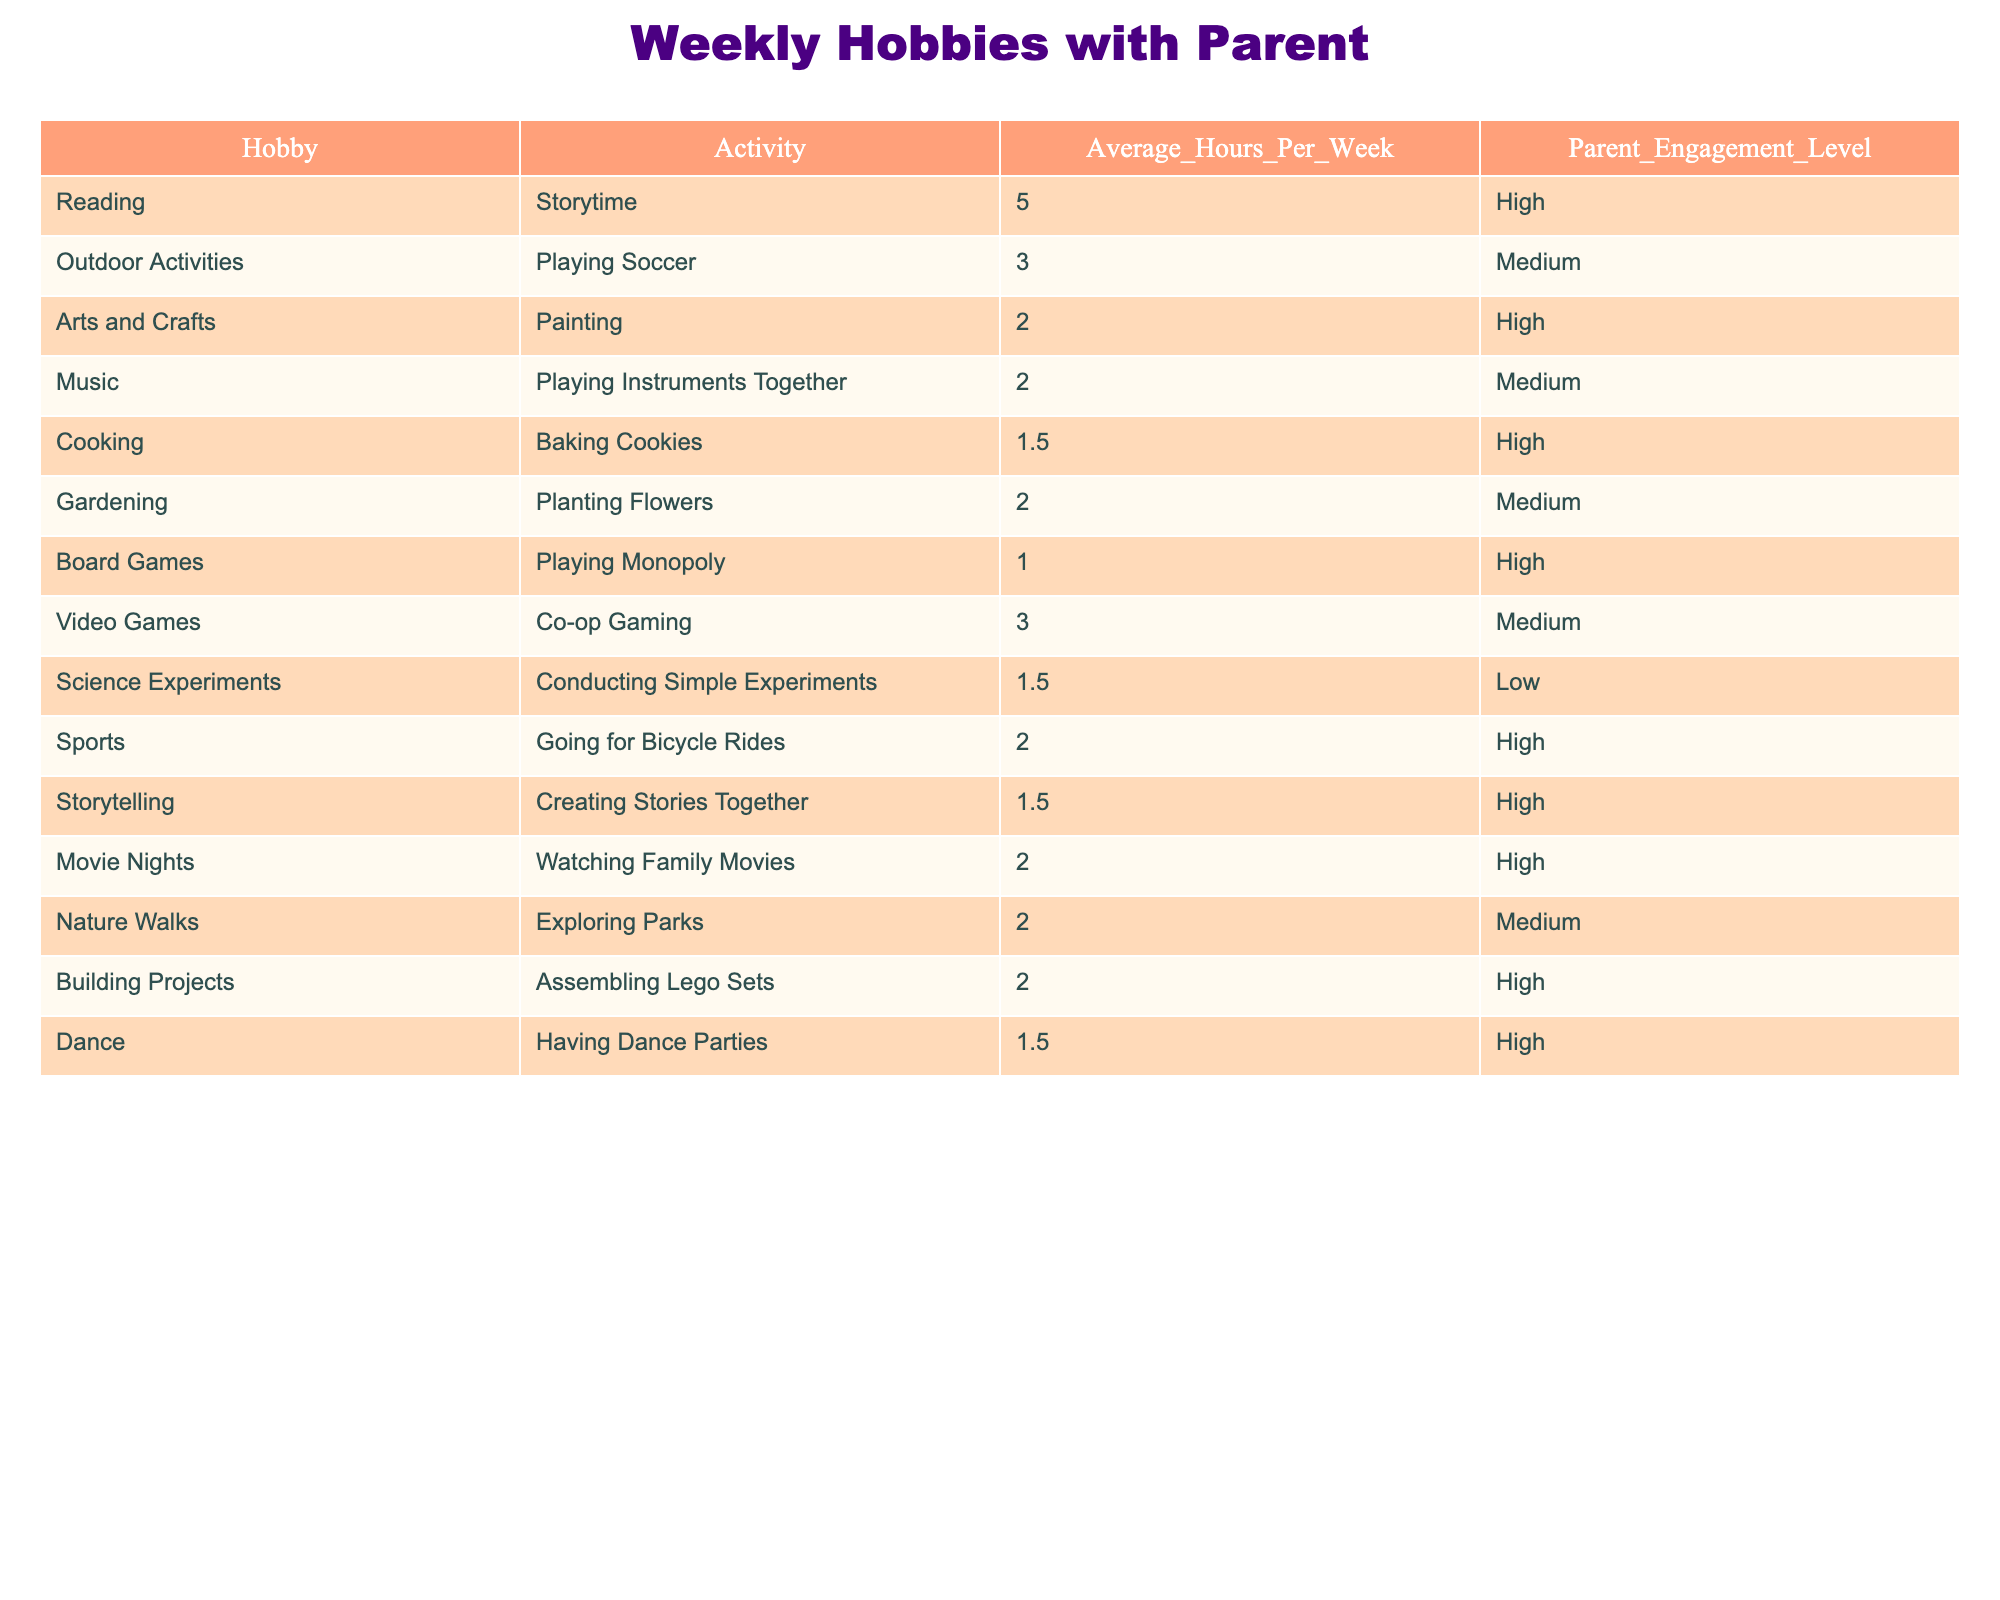What's the average time spent on Reading? The time spent on Reading is 5 hours per week. There is only one row for Reading, so the average is simply 5.
Answer: 5 hours How many hobbies have a High Parent Engagement Level? I can count the rows where Parent Engagement Level is High. There are 7 hobbies: Reading, Arts and Crafts, Cooking, Sports, Storytelling, Movie Nights, and Building Projects.
Answer: 7 hobbies What is the total average time spent on Outdoor Activities and Video Games? First, I find the average hours for Outdoor Activities, which is 3, and for Video Games, which is also 3. Then, I sum these two values: 3 + 3 = 6 hours.
Answer: 6 hours Is Cooking considered a hobby with High Parent Engagement Level? According to the table, Cooking has an Engagement Level of High, as indicated in the corresponding row.
Answer: Yes Which hobby has the least average hours spent per week? By examining the Average Hours Per Week column, I can see that Board Games has the least hours spent with only 1 hour.
Answer: Board Games If we compare the average hours of Music with the average hours of Video Games, which one is higher? The average hours for Music is 2, while for Video Games it is 3. Since 3 is greater than 2, Video Games has more hours.
Answer: Video Games What is the total average hours spent on all hobbies with a Medium Parent Engagement Level? First, I need to identify the hobbies with Medium Engagement: Outdoor Activities (3), Music (2), Gardening (2), Video Games (3), and Nature Walks (2). Then, I add them up: 3 + 2 + 2 + 3 + 2 = 12 hours. Finally, I check how many hobbies there are (5), so the average is 12/5 = 2.4.
Answer: 2.4 hours Are there more hobbies with High Engagement than Medium Engagement? Counting the hobbies, there are 7 with High Engagement and 5 with Medium Engagement. Since 7 is greater than 5, there are more High Engagement hobbies.
Answer: Yes What hobbies have the same average hours of 2? Looking closely, I can see that there are three hobbies with 2 hours each: Arts and Crafts, Gardening, and Nature Walks.
Answer: Arts and Crafts, Gardening, Nature Walks 